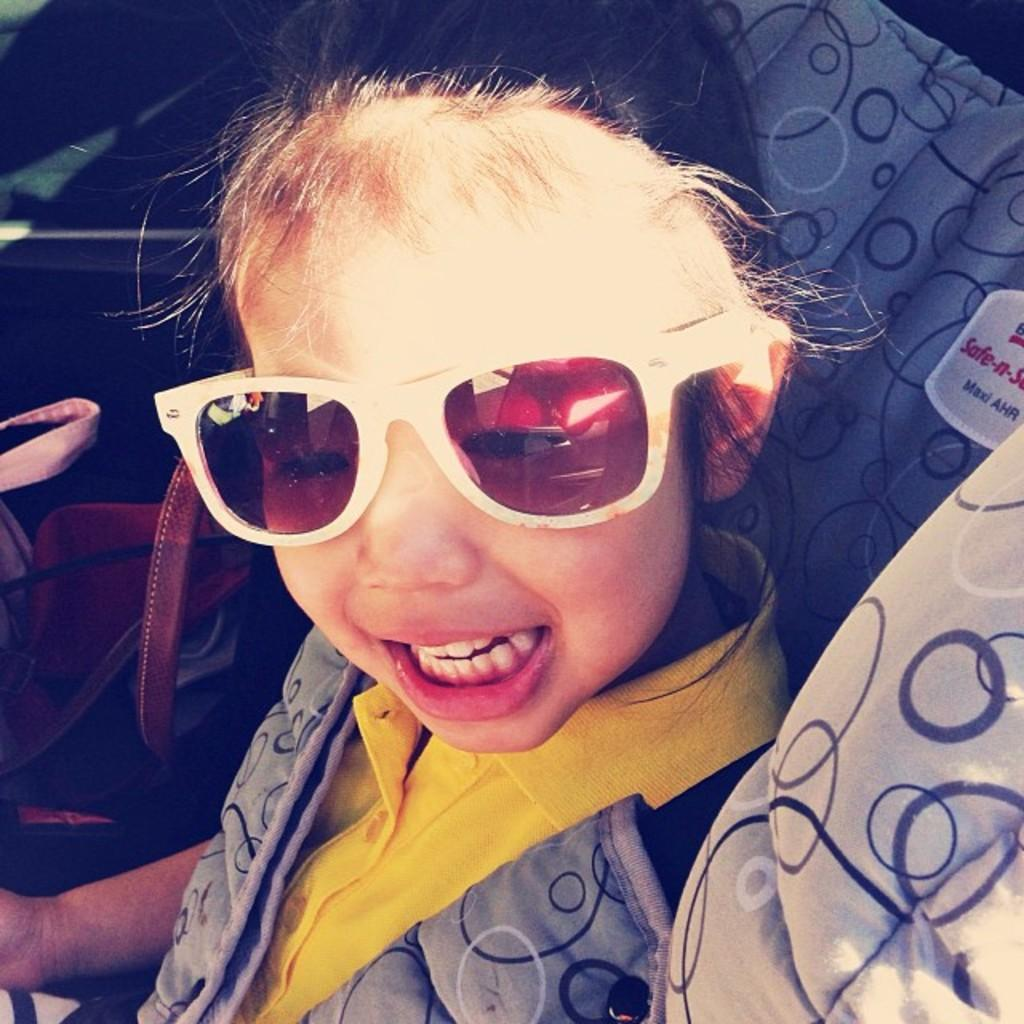What is the main subject of the picture? The main subject of the picture is a kid. What can be observed about the kid's appearance? The kid is wearing spectacles. What other object is visible in the picture? There is a holder visible in the picture. What type of roof can be seen on the collar in the image? There is no roof or collar present in the image. 